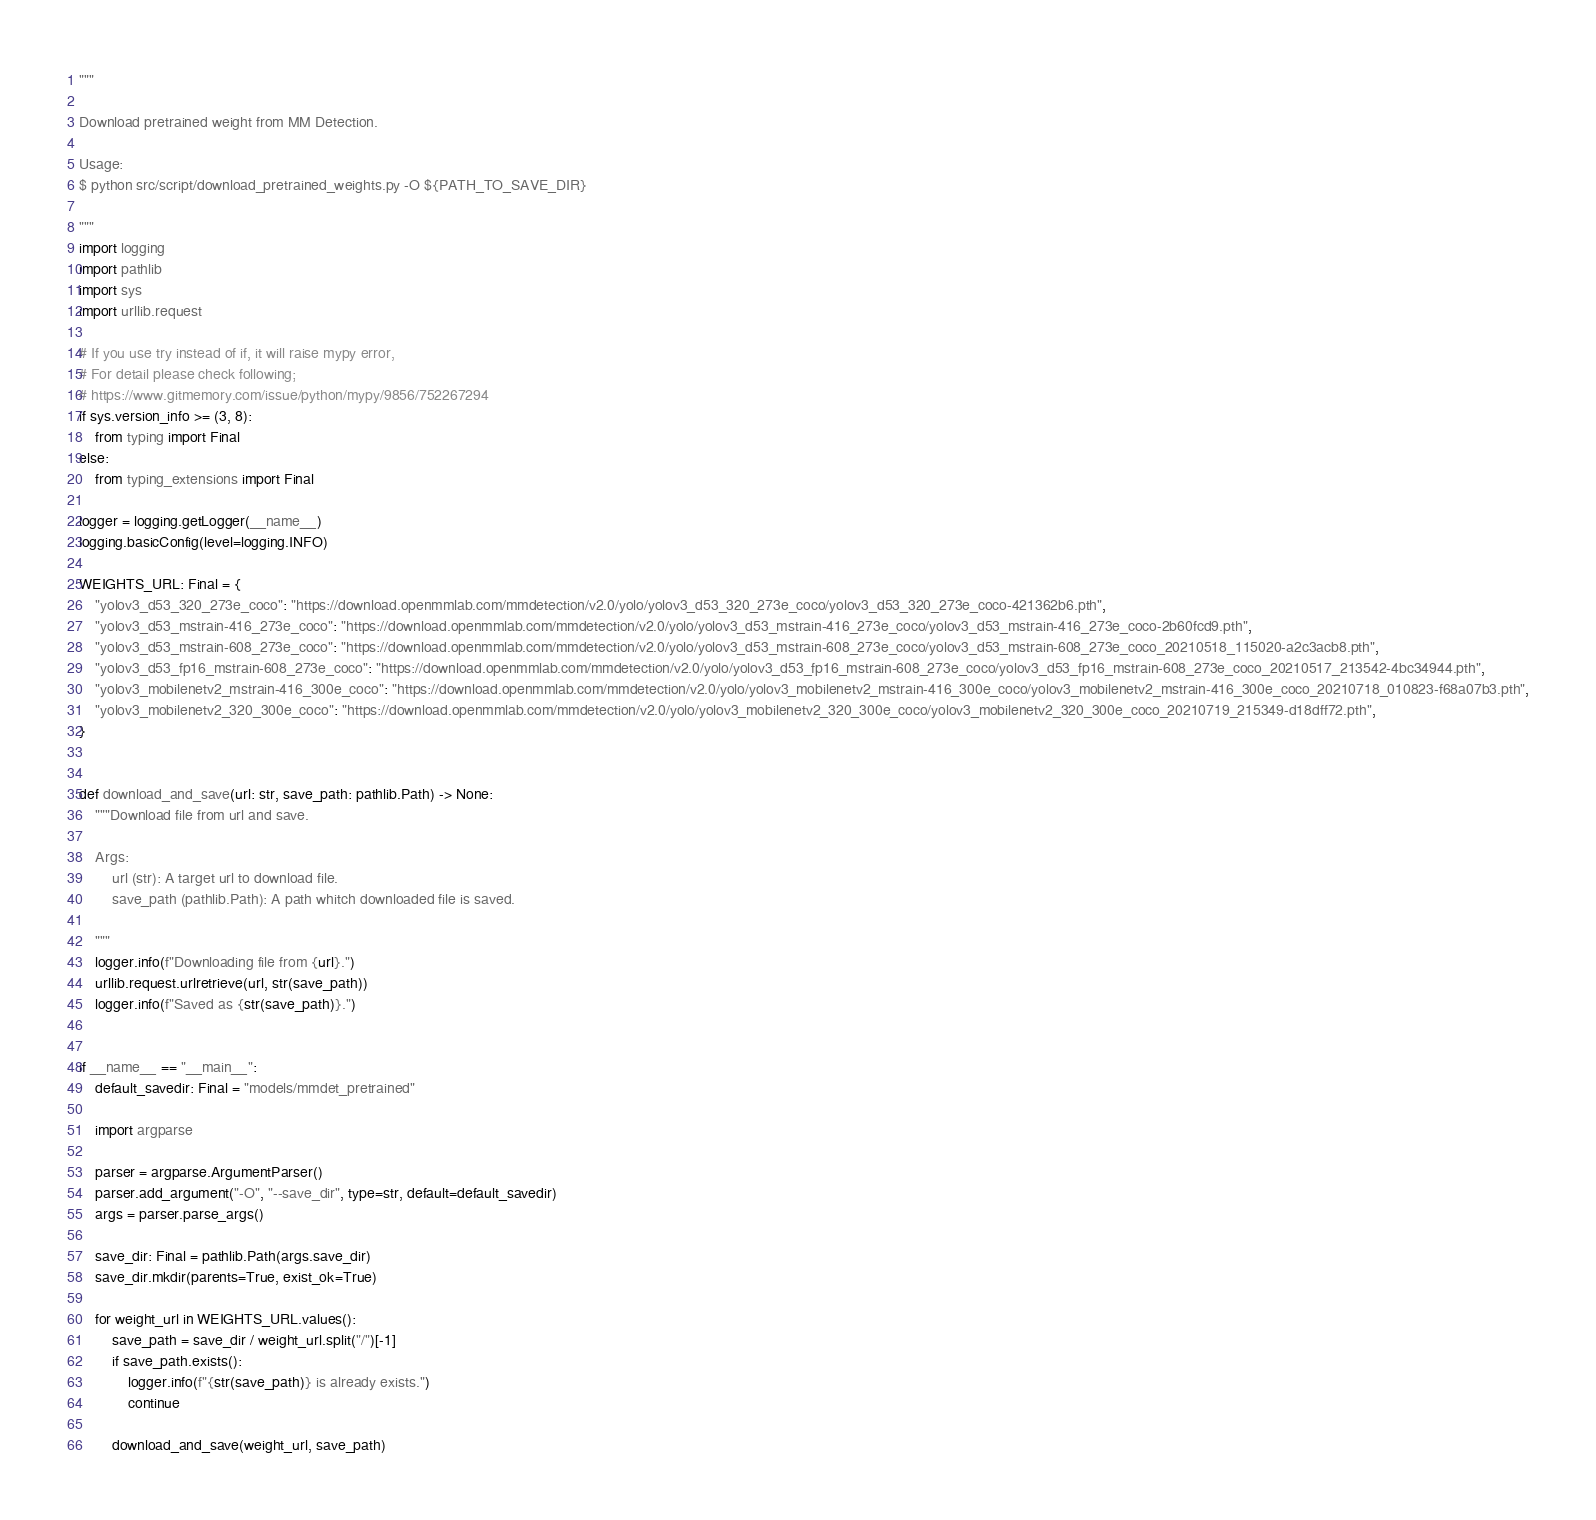Convert code to text. <code><loc_0><loc_0><loc_500><loc_500><_Python_>"""

Download pretrained weight from MM Detection.

Usage:
$ python src/script/download_pretrained_weights.py -O ${PATH_TO_SAVE_DIR}

"""
import logging
import pathlib
import sys
import urllib.request

# If you use try instead of if, it will raise mypy error,
# For detail please check following;
# https://www.gitmemory.com/issue/python/mypy/9856/752267294
if sys.version_info >= (3, 8):
    from typing import Final
else:
    from typing_extensions import Final

logger = logging.getLogger(__name__)
logging.basicConfig(level=logging.INFO)

WEIGHTS_URL: Final = {
    "yolov3_d53_320_273e_coco": "https://download.openmmlab.com/mmdetection/v2.0/yolo/yolov3_d53_320_273e_coco/yolov3_d53_320_273e_coco-421362b6.pth",
    "yolov3_d53_mstrain-416_273e_coco": "https://download.openmmlab.com/mmdetection/v2.0/yolo/yolov3_d53_mstrain-416_273e_coco/yolov3_d53_mstrain-416_273e_coco-2b60fcd9.pth",
    "yolov3_d53_mstrain-608_273e_coco": "https://download.openmmlab.com/mmdetection/v2.0/yolo/yolov3_d53_mstrain-608_273e_coco/yolov3_d53_mstrain-608_273e_coco_20210518_115020-a2c3acb8.pth",
    "yolov3_d53_fp16_mstrain-608_273e_coco": "https://download.openmmlab.com/mmdetection/v2.0/yolo/yolov3_d53_fp16_mstrain-608_273e_coco/yolov3_d53_fp16_mstrain-608_273e_coco_20210517_213542-4bc34944.pth",
    "yolov3_mobilenetv2_mstrain-416_300e_coco": "https://download.openmmlab.com/mmdetection/v2.0/yolo/yolov3_mobilenetv2_mstrain-416_300e_coco/yolov3_mobilenetv2_mstrain-416_300e_coco_20210718_010823-f68a07b3.pth",
    "yolov3_mobilenetv2_320_300e_coco": "https://download.openmmlab.com/mmdetection/v2.0/yolo/yolov3_mobilenetv2_320_300e_coco/yolov3_mobilenetv2_320_300e_coco_20210719_215349-d18dff72.pth",
}


def download_and_save(url: str, save_path: pathlib.Path) -> None:
    """Download file from url and save.

    Args:
        url (str): A target url to download file.
        save_path (pathlib.Path): A path whitch downloaded file is saved.

    """
    logger.info(f"Downloading file from {url}.")
    urllib.request.urlretrieve(url, str(save_path))
    logger.info(f"Saved as {str(save_path)}.")


if __name__ == "__main__":
    default_savedir: Final = "models/mmdet_pretrained"

    import argparse

    parser = argparse.ArgumentParser()
    parser.add_argument("-O", "--save_dir", type=str, default=default_savedir)
    args = parser.parse_args()

    save_dir: Final = pathlib.Path(args.save_dir)
    save_dir.mkdir(parents=True, exist_ok=True)

    for weight_url in WEIGHTS_URL.values():
        save_path = save_dir / weight_url.split("/")[-1]
        if save_path.exists():
            logger.info(f"{str(save_path)} is already exists.")
            continue

        download_and_save(weight_url, save_path)
</code> 